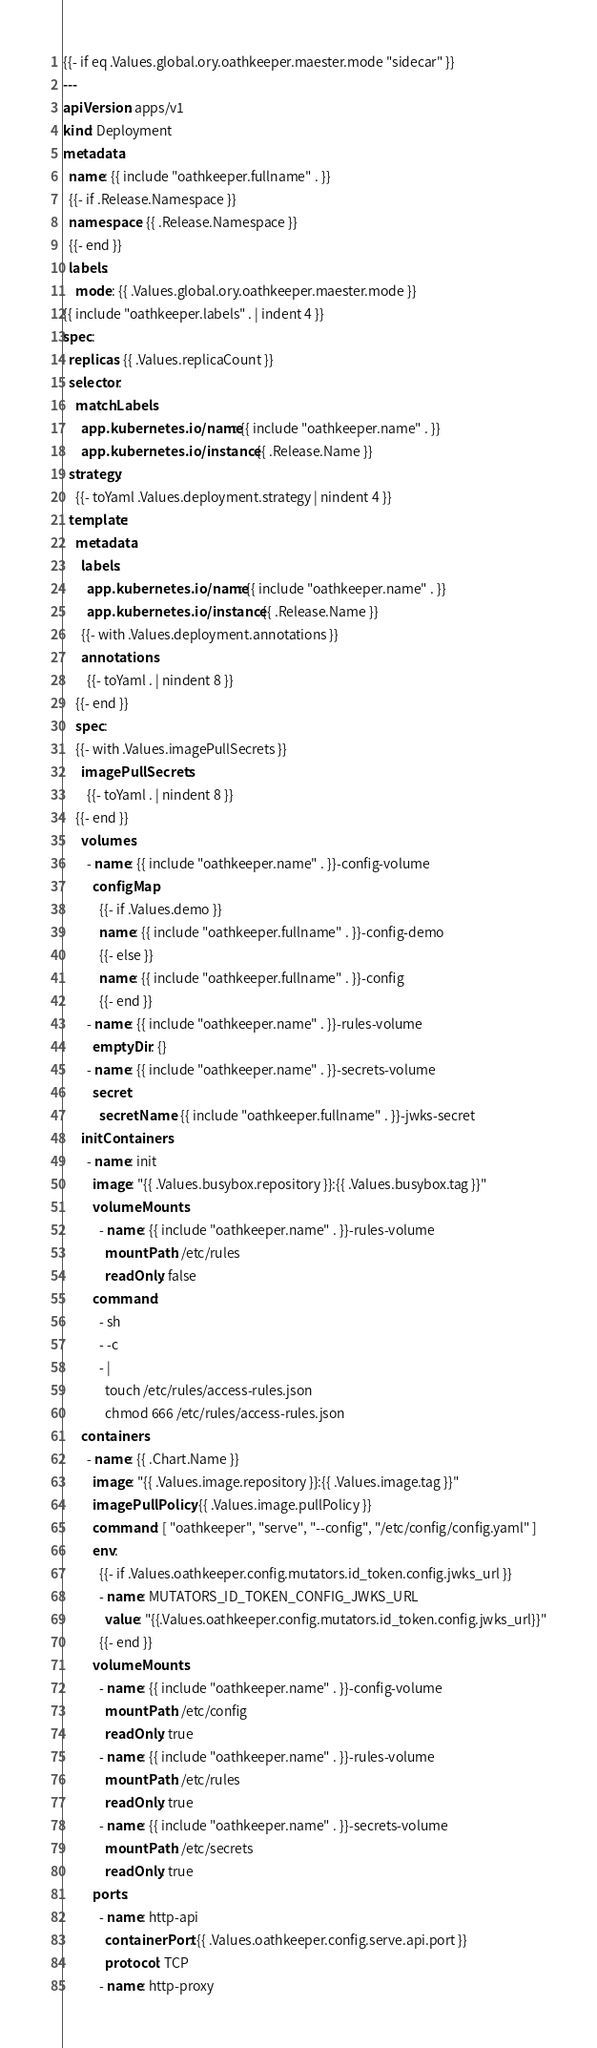<code> <loc_0><loc_0><loc_500><loc_500><_YAML_>{{- if eq .Values.global.ory.oathkeeper.maester.mode "sidecar" }}
---
apiVersion: apps/v1
kind: Deployment
metadata:
  name: {{ include "oathkeeper.fullname" . }}
  {{- if .Release.Namespace }}
  namespace: {{ .Release.Namespace }}
  {{- end }}
  labels:
    mode: {{ .Values.global.ory.oathkeeper.maester.mode }}
{{ include "oathkeeper.labels" . | indent 4 }}
spec:
  replicas: {{ .Values.replicaCount }}
  selector:
    matchLabels:
      app.kubernetes.io/name: {{ include "oathkeeper.name" . }}
      app.kubernetes.io/instance: {{ .Release.Name }}
  strategy:
    {{- toYaml .Values.deployment.strategy | nindent 4 }}
  template:
    metadata:
      labels:
        app.kubernetes.io/name: {{ include "oathkeeper.name" . }}
        app.kubernetes.io/instance: {{ .Release.Name }}
      {{- with .Values.deployment.annotations }}
      annotations:
        {{- toYaml . | nindent 8 }}
    {{- end }}
    spec:
    {{- with .Values.imagePullSecrets }}
      imagePullSecrets:
        {{- toYaml . | nindent 8 }}
    {{- end }}
      volumes:
        - name: {{ include "oathkeeper.name" . }}-config-volume
          configMap:
            {{- if .Values.demo }}
            name: {{ include "oathkeeper.fullname" . }}-config-demo
            {{- else }}
            name: {{ include "oathkeeper.fullname" . }}-config
            {{- end }}
        - name: {{ include "oathkeeper.name" . }}-rules-volume
          emptyDir: {}
        - name: {{ include "oathkeeper.name" . }}-secrets-volume
          secret:
            secretName: {{ include "oathkeeper.fullname" . }}-jwks-secret
      initContainers:
        - name: init
          image: "{{ .Values.busybox.repository }}:{{ .Values.busybox.tag }}"
          volumeMounts:
            - name: {{ include "oathkeeper.name" . }}-rules-volume
              mountPath: /etc/rules
              readOnly: false
          command:
            - sh
            - -c
            - |
              touch /etc/rules/access-rules.json
              chmod 666 /etc/rules/access-rules.json
      containers:
        - name: {{ .Chart.Name }}
          image: "{{ .Values.image.repository }}:{{ .Values.image.tag }}"
          imagePullPolicy: {{ .Values.image.pullPolicy }}
          command: [ "oathkeeper", "serve", "--config", "/etc/config/config.yaml" ]
          env:
            {{- if .Values.oathkeeper.config.mutators.id_token.config.jwks_url }}
            - name: MUTATORS_ID_TOKEN_CONFIG_JWKS_URL
              value: "{{.Values.oathkeeper.config.mutators.id_token.config.jwks_url}}"
            {{- end }}
          volumeMounts:
            - name: {{ include "oathkeeper.name" . }}-config-volume
              mountPath: /etc/config
              readOnly: true
            - name: {{ include "oathkeeper.name" . }}-rules-volume
              mountPath: /etc/rules
              readOnly: true
            - name: {{ include "oathkeeper.name" . }}-secrets-volume
              mountPath: /etc/secrets
              readOnly: true
          ports:
            - name: http-api
              containerPort: {{ .Values.oathkeeper.config.serve.api.port }}
              protocol: TCP
            - name: http-proxy</code> 